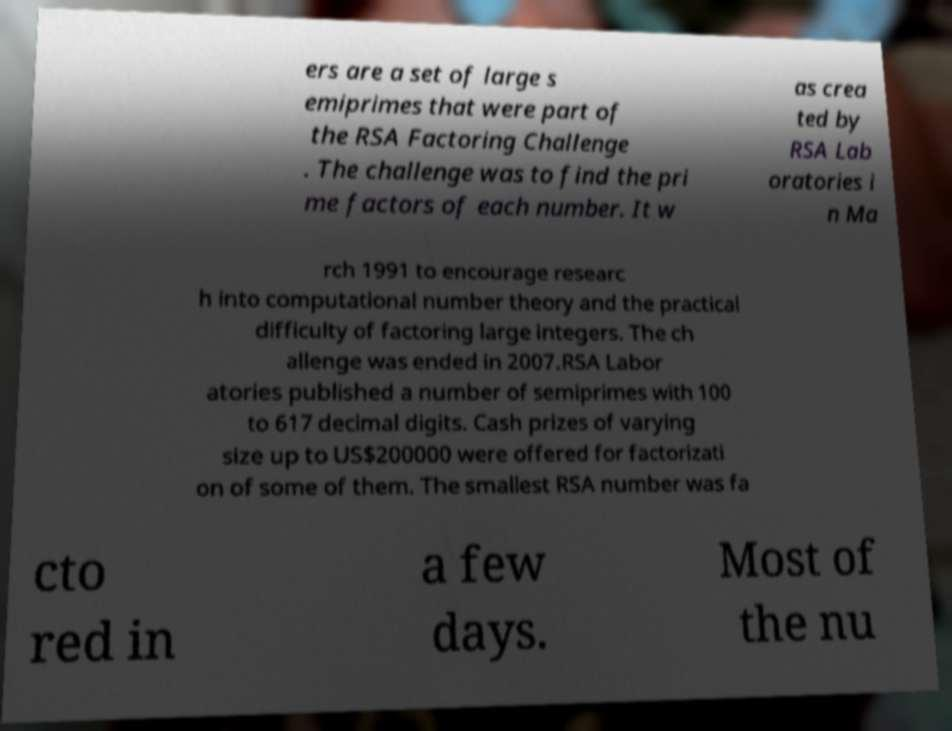I need the written content from this picture converted into text. Can you do that? ers are a set of large s emiprimes that were part of the RSA Factoring Challenge . The challenge was to find the pri me factors of each number. It w as crea ted by RSA Lab oratories i n Ma rch 1991 to encourage researc h into computational number theory and the practical difficulty of factoring large integers. The ch allenge was ended in 2007.RSA Labor atories published a number of semiprimes with 100 to 617 decimal digits. Cash prizes of varying size up to US$200000 were offered for factorizati on of some of them. The smallest RSA number was fa cto red in a few days. Most of the nu 